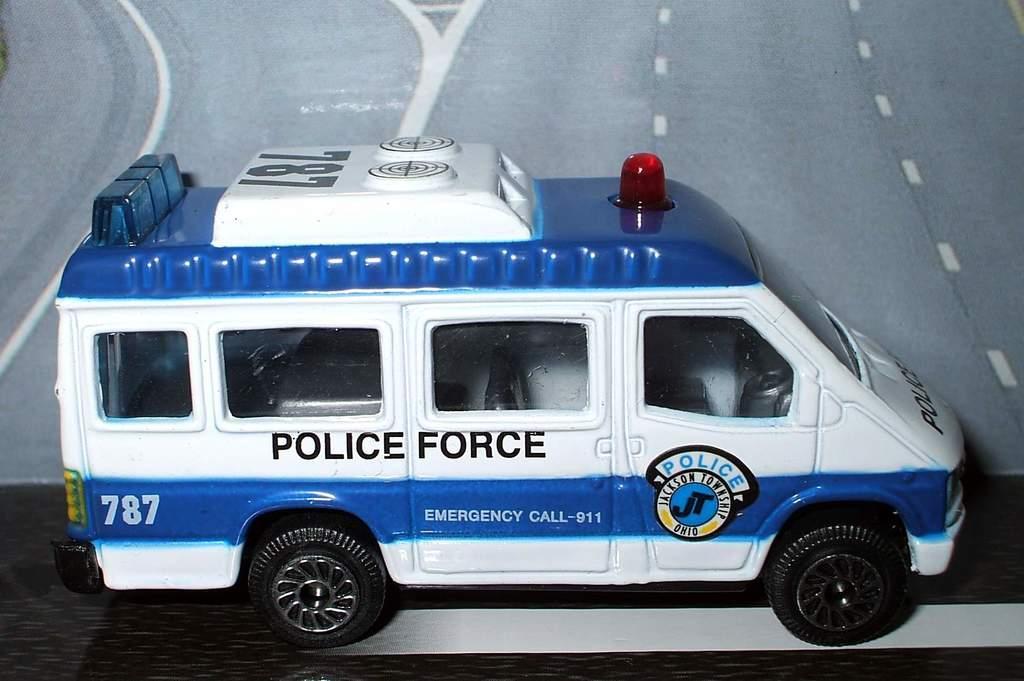Could you give a brief overview of what you see in this image? The picture consists of a toy which is like a police van. At the bottom it is like a road. 